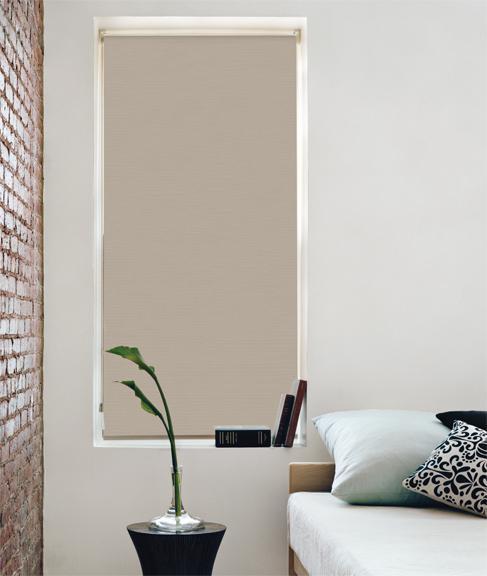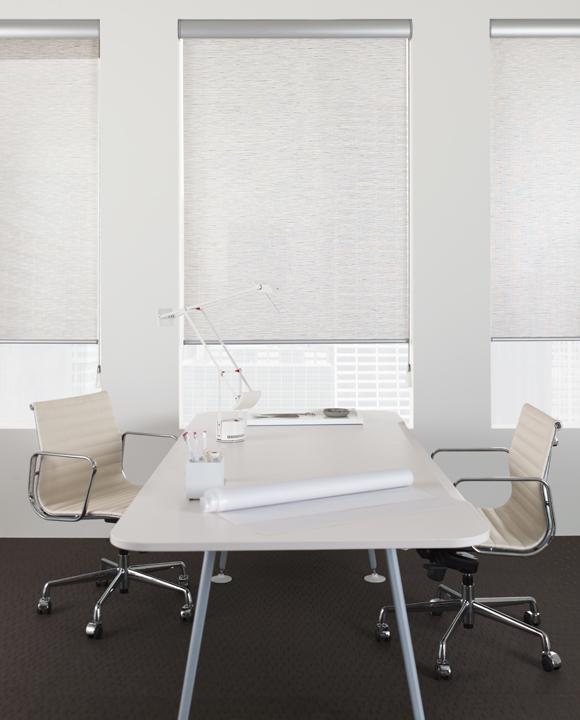The first image is the image on the left, the second image is the image on the right. Assess this claim about the two images: "In at least one image there are two blinds that are both open at different levels.". Correct or not? Answer yes or no. No. The first image is the image on the left, the second image is the image on the right. For the images shown, is this caption "The left image shows a chair to the right of a window with a pattern-printed window shade." true? Answer yes or no. No. 